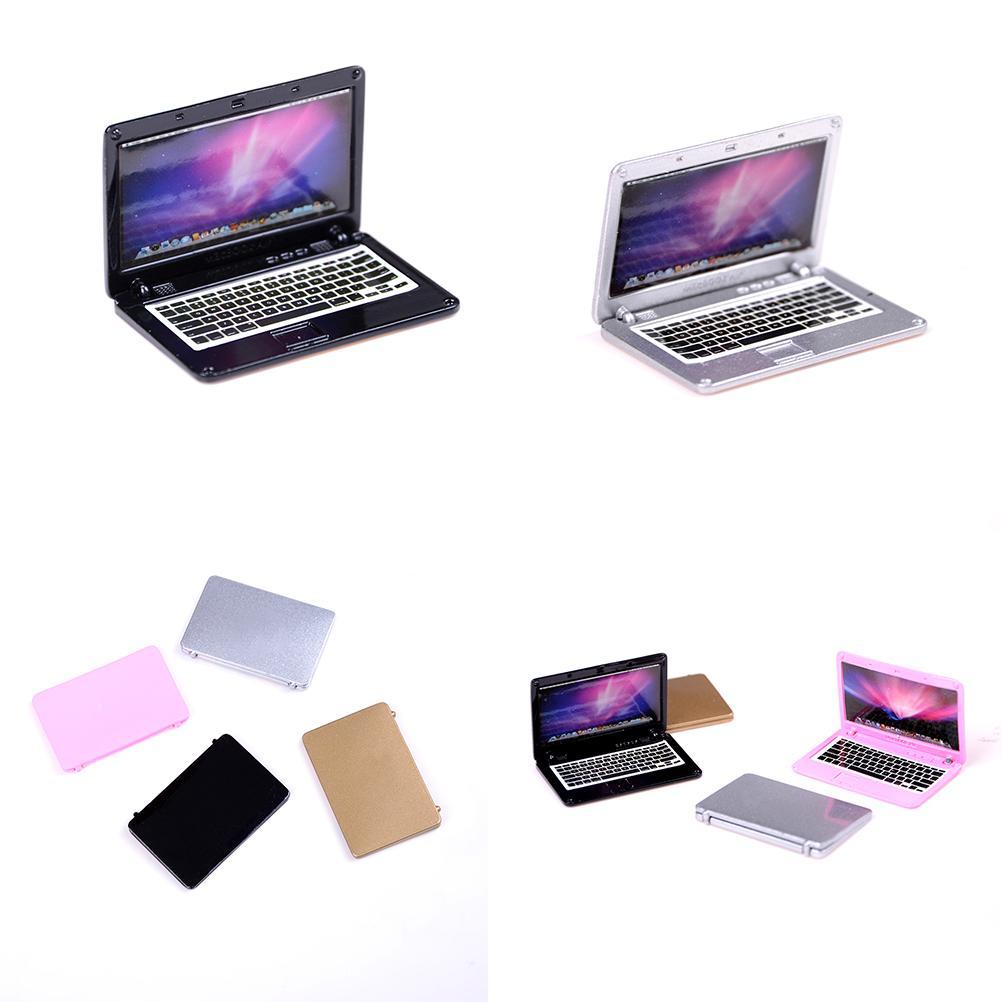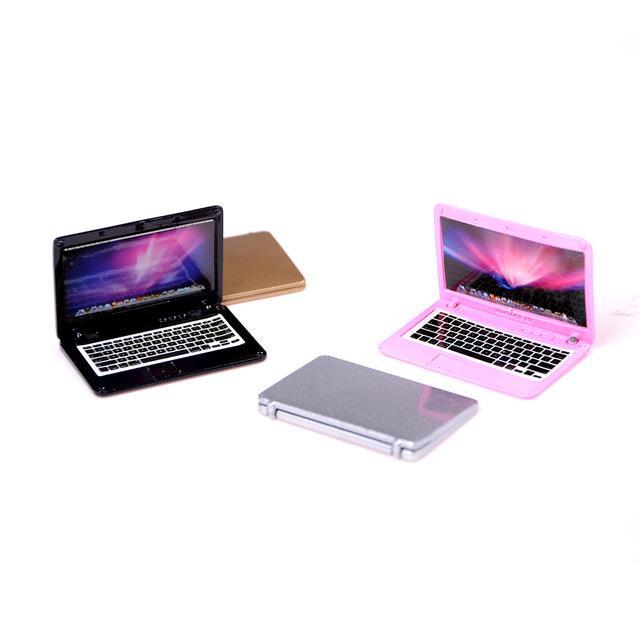The first image is the image on the left, the second image is the image on the right. For the images shown, is this caption "No single image contains more than two devices, and at least one image shows a hand holding a small white open device." true? Answer yes or no. No. The first image is the image on the left, the second image is the image on the right. Examine the images to the left and right. Is the description "There are two miniature laptops." accurate? Answer yes or no. No. 